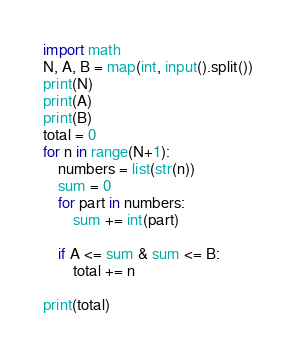Convert code to text. <code><loc_0><loc_0><loc_500><loc_500><_Python_>import math
N, A, B = map(int, input().split())
print(N)
print(A)
print(B)
total = 0
for n in range(N+1):
	numbers = list(str(n))
	sum = 0
	for part in numbers:
		sum += int(part)
	
	if A <= sum & sum <= B:
		total += n
		
print(total) </code> 